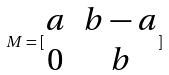<formula> <loc_0><loc_0><loc_500><loc_500>M = [ \begin{matrix} a & b - a \\ 0 & b \end{matrix} ]</formula> 